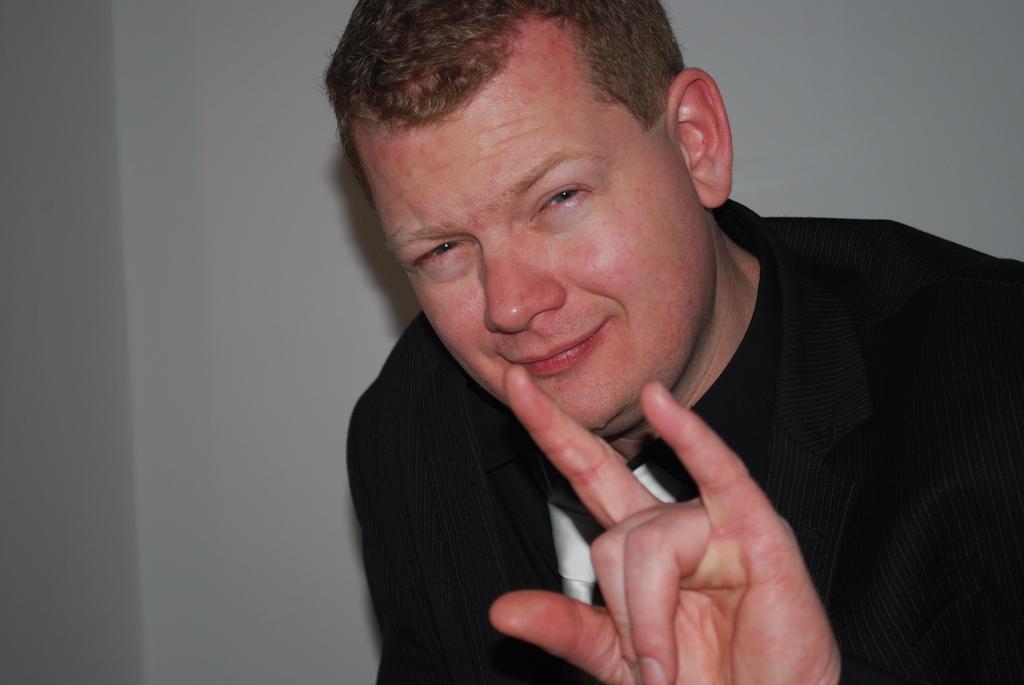Please provide a concise description of this image. In this image there is a person wearing black suit. He is before a wall. 